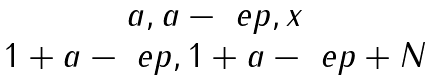<formula> <loc_0><loc_0><loc_500><loc_500>\begin{matrix} { a , a - \ e p , x } \\ { 1 + a - \ e p , 1 + a - \ e p + N } \end{matrix}</formula> 